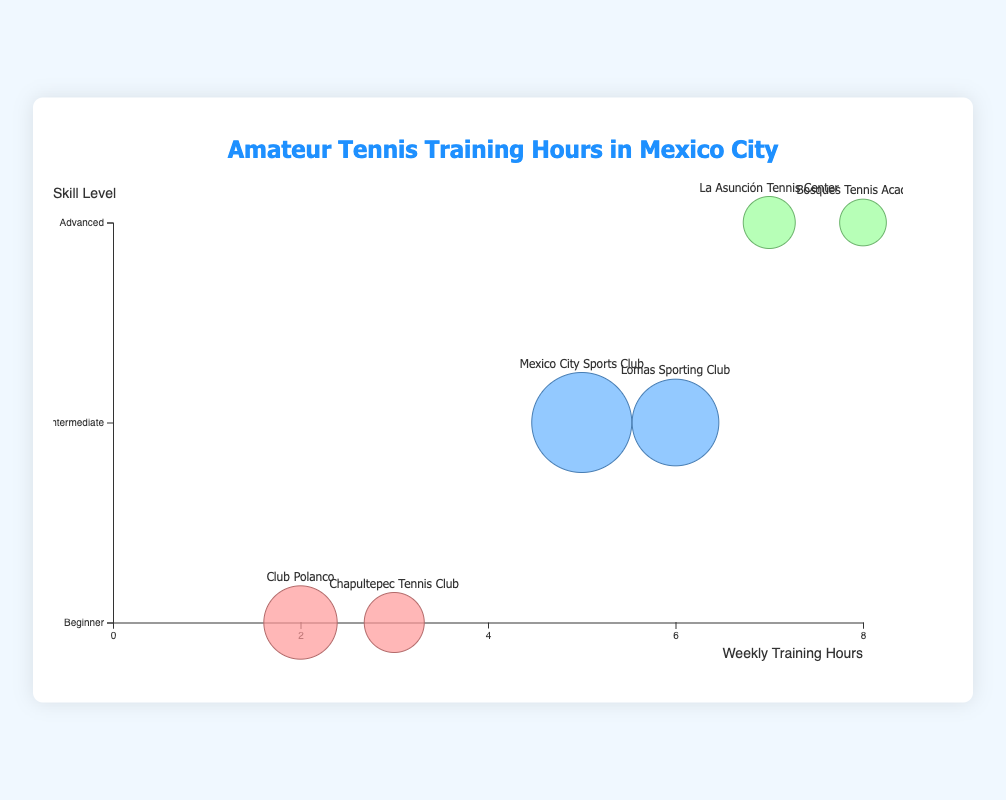What is the title of the chart? The title is displayed at the top of the chart.
Answer: Amateur Tennis Training Hours in Mexico City What does the X-axis represent? The X-axis label indicates what it measures. It is marked "Weekly Training Hours".
Answer: Weekly Training Hours Which club has the highest number of players? By comparing the size of the bubbles, the largest bubble corresponds to the club with the most players, which is Mexico City Sports Club with 30 players.
Answer: Mexico City Sports Club How many skill levels are represented in the chart? Look at the labels on the Y-axis. They indicate the number of skill levels represented. There are three levels: Beginner, Intermediate, and Advanced.
Answer: 3 Which skill level has the highest average weekly training hours? Identify the highest value on the X-axis for each skill level. Advanced skill level has the highest average weekly training hours, with Bosques Tennis Academy at 8 hours and La Asunción Tennis Center at 7 hours.
Answer: Advanced What is the average weekly training hours for intermediate players? Find the intermediate skill level data points and calculate the average: (5 hours + 6 hours) / 2. This results in (5 + 6) / 2 = 11 / 2 = 5.5.
Answer: 5.5 Compare the weekly training hours of Advanced players. Which club has more training hours? For Advanced skill level, compare the X-axis values for Bosques Tennis Academy and La Asunción Tennis Center. Bosques Tennis Academy has 8 hours, which is more than La Asunción Tennis Center with 7 hours.
Answer: Bosques Tennis Academy How many clubs have beginner players? Count the number of bubbles corresponding to the Beginner skill level on the Y-axis. Two clubs are represented there: Club Polanco and Chapultepec Tennis Club.
Answer: 2 What is the total number of players in the Intermediate skill level? Add the number of players from the Intermediate level bubbles: Mexico City Sports Club (30) and Lomas Sporting Club (25). The total is 30 + 25 = 55.
Answer: 55 Which club has the least number of players, and how many players does it have? Find the smallest bubble on the chart, which represents Bosques Tennis Academy. It has the least number of players with 10 players.
Answer: Bosques Tennis Academy, 10 